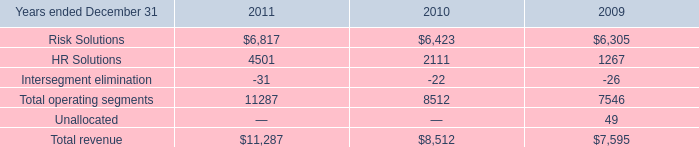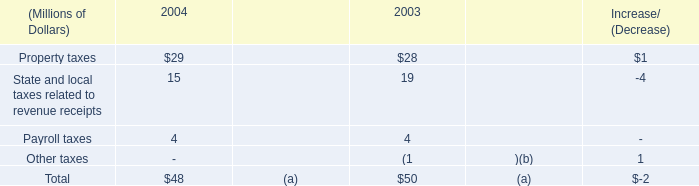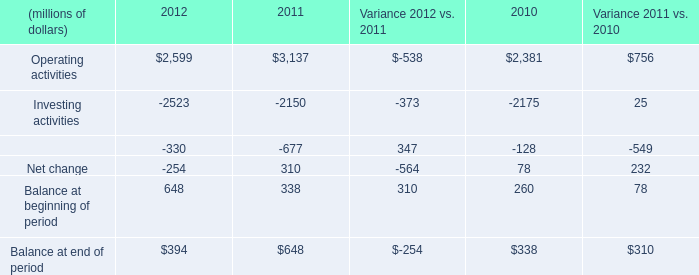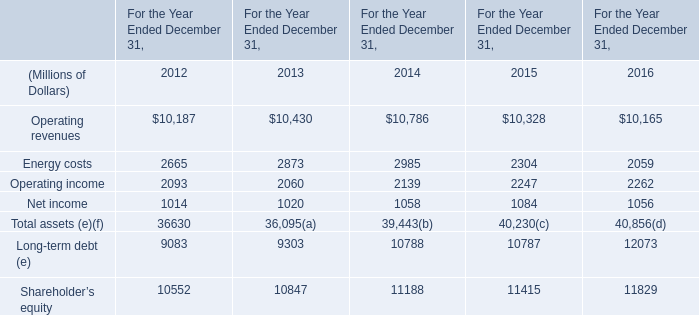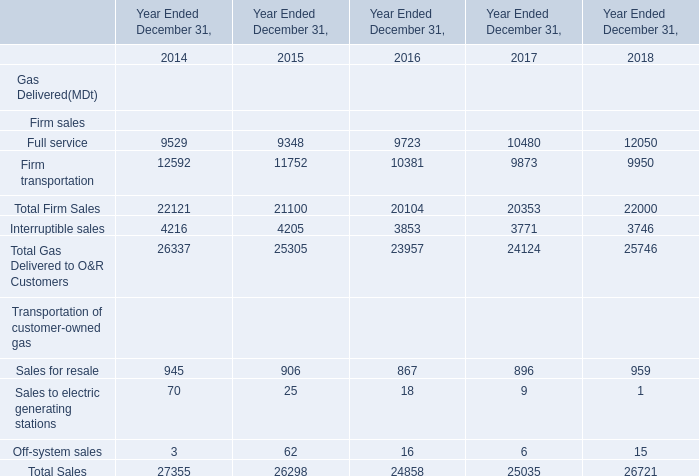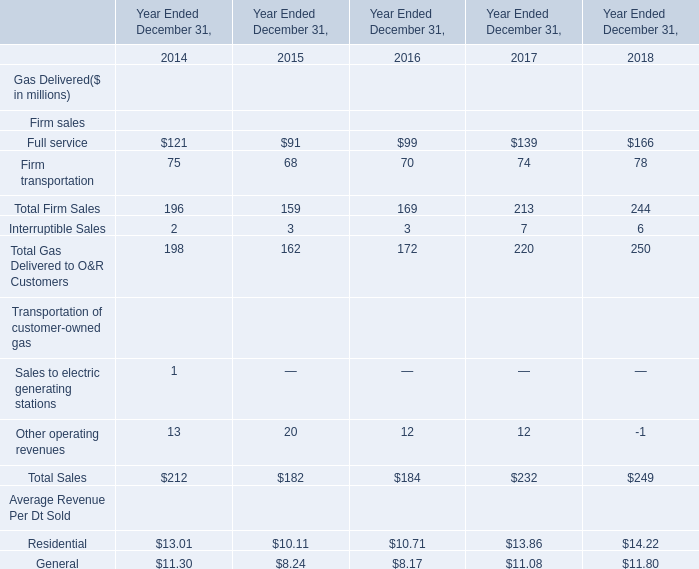What is the sum of the Sales to electric generating stations in the years where Off-system sales is greater than 15? 
Computations: (25 + 18)
Answer: 43.0. 